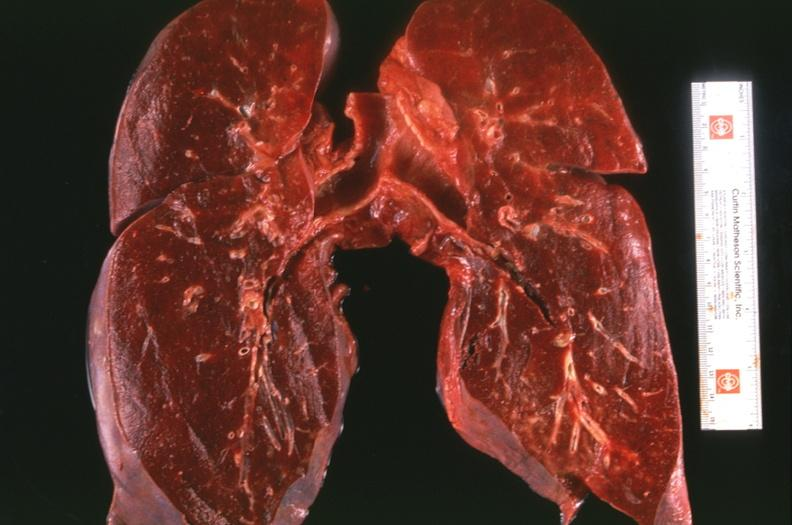what does this image show?
Answer the question using a single word or phrase. Lung 